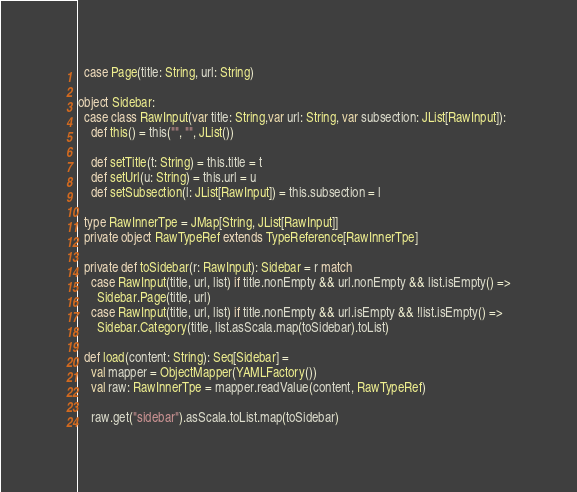<code> <loc_0><loc_0><loc_500><loc_500><_Scala_>  case Page(title: String, url: String)

object Sidebar:
  case class RawInput(var title: String,var url: String, var subsection: JList[RawInput]):
    def this() = this("", "", JList())

    def setTitle(t: String) = this.title = t
    def setUrl(u: String) = this.url = u
    def setSubsection(l: JList[RawInput]) = this.subsection = l

  type RawInnerTpe = JMap[String, JList[RawInput]]
  private object RawTypeRef extends TypeReference[RawInnerTpe]

  private def toSidebar(r: RawInput): Sidebar = r match
    case RawInput(title, url, list) if title.nonEmpty && url.nonEmpty && list.isEmpty() =>
      Sidebar.Page(title, url)
    case RawInput(title, url, list) if title.nonEmpty && url.isEmpty && !list.isEmpty() =>
      Sidebar.Category(title, list.asScala.map(toSidebar).toList)

  def load(content: String): Seq[Sidebar] =
    val mapper = ObjectMapper(YAMLFactory())
    val raw: RawInnerTpe = mapper.readValue(content, RawTypeRef)

    raw.get("sidebar").asScala.toList.map(toSidebar)
</code> 